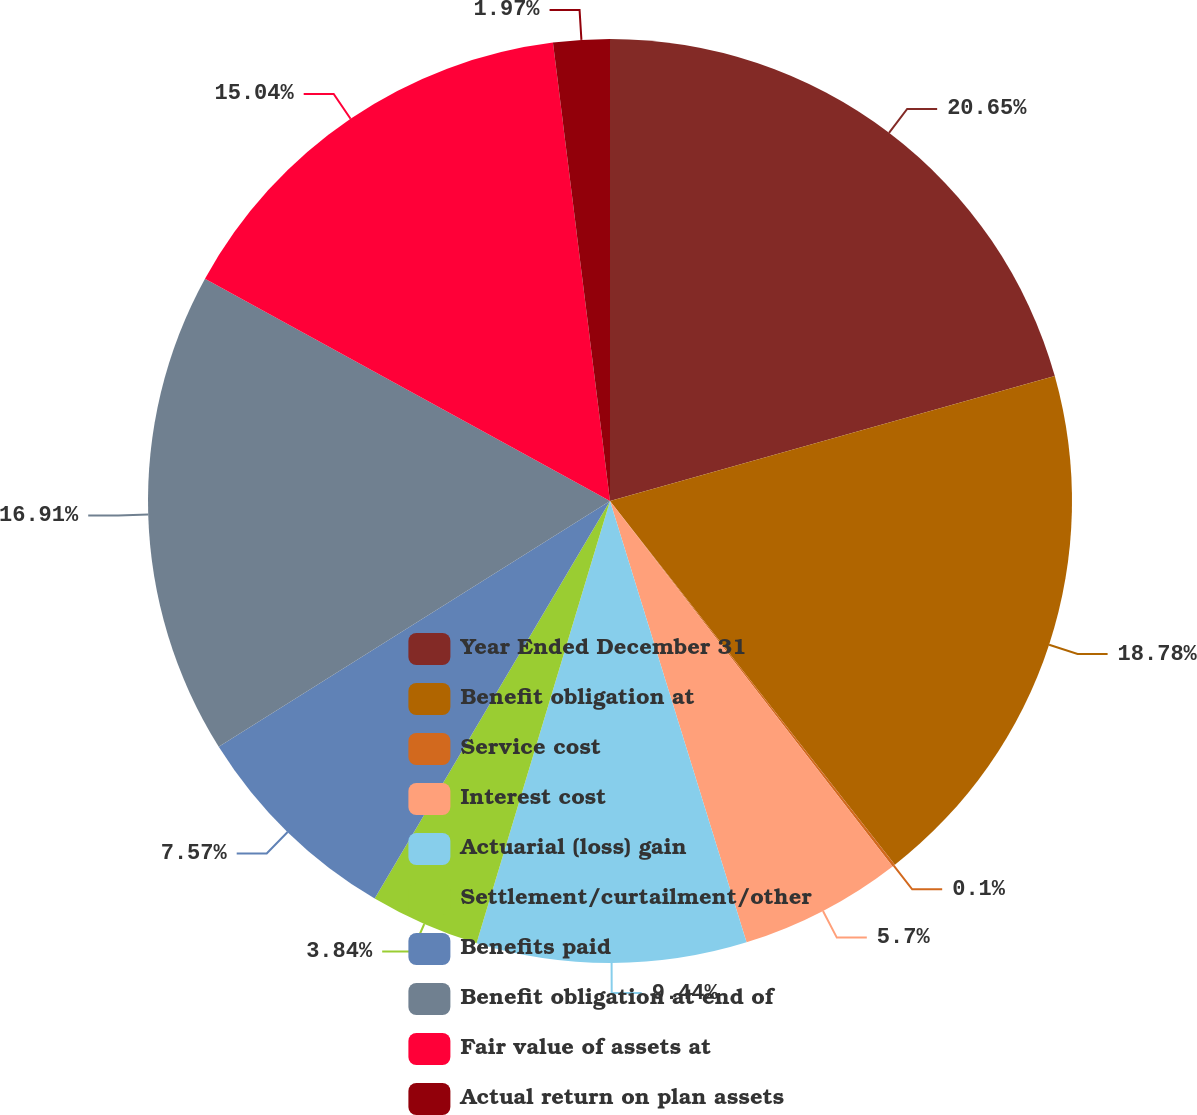Convert chart to OTSL. <chart><loc_0><loc_0><loc_500><loc_500><pie_chart><fcel>Year Ended December 31<fcel>Benefit obligation at<fcel>Service cost<fcel>Interest cost<fcel>Actuarial (loss) gain<fcel>Settlement/curtailment/other<fcel>Benefits paid<fcel>Benefit obligation at end of<fcel>Fair value of assets at<fcel>Actual return on plan assets<nl><fcel>20.64%<fcel>18.78%<fcel>0.1%<fcel>5.7%<fcel>9.44%<fcel>3.84%<fcel>7.57%<fcel>16.91%<fcel>15.04%<fcel>1.97%<nl></chart> 